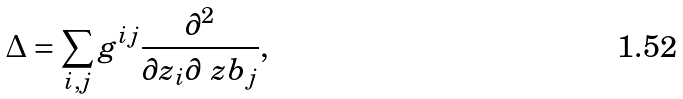Convert formula to latex. <formula><loc_0><loc_0><loc_500><loc_500>\Delta = \sum _ { i , j } g ^ { i j } \frac { \partial ^ { 2 } } { \partial z _ { i } \partial \ z b _ { j } } ,</formula> 